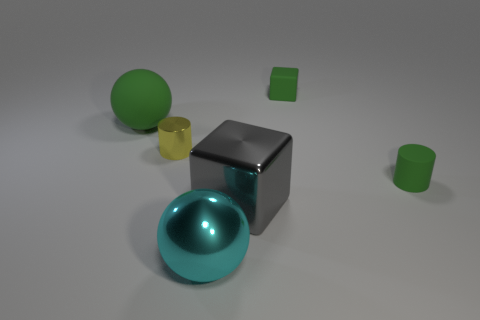Is the size of the gray object that is right of the large cyan object the same as the green rubber object that is to the left of the big metal ball?
Make the answer very short. Yes. There is a block that is the same size as the cyan ball; what is it made of?
Keep it short and to the point. Metal. There is a big thing that is both left of the large block and on the right side of the yellow metal cylinder; what is its material?
Your answer should be very brief. Metal. Is there a big red object?
Your answer should be very brief. No. Do the large rubber thing and the big shiny thing that is left of the big cube have the same color?
Offer a terse response. No. There is a tiny cylinder that is the same color as the matte sphere; what is its material?
Offer a terse response. Rubber. Are there any other things that are the same shape as the cyan thing?
Offer a terse response. Yes. There is a green matte object to the left of the tiny cylinder that is on the left side of the rubber object on the right side of the tiny matte block; what is its shape?
Provide a succinct answer. Sphere. There is a small yellow shiny object; what shape is it?
Offer a very short reply. Cylinder. What color is the large ball behind the gray object?
Ensure brevity in your answer.  Green. 